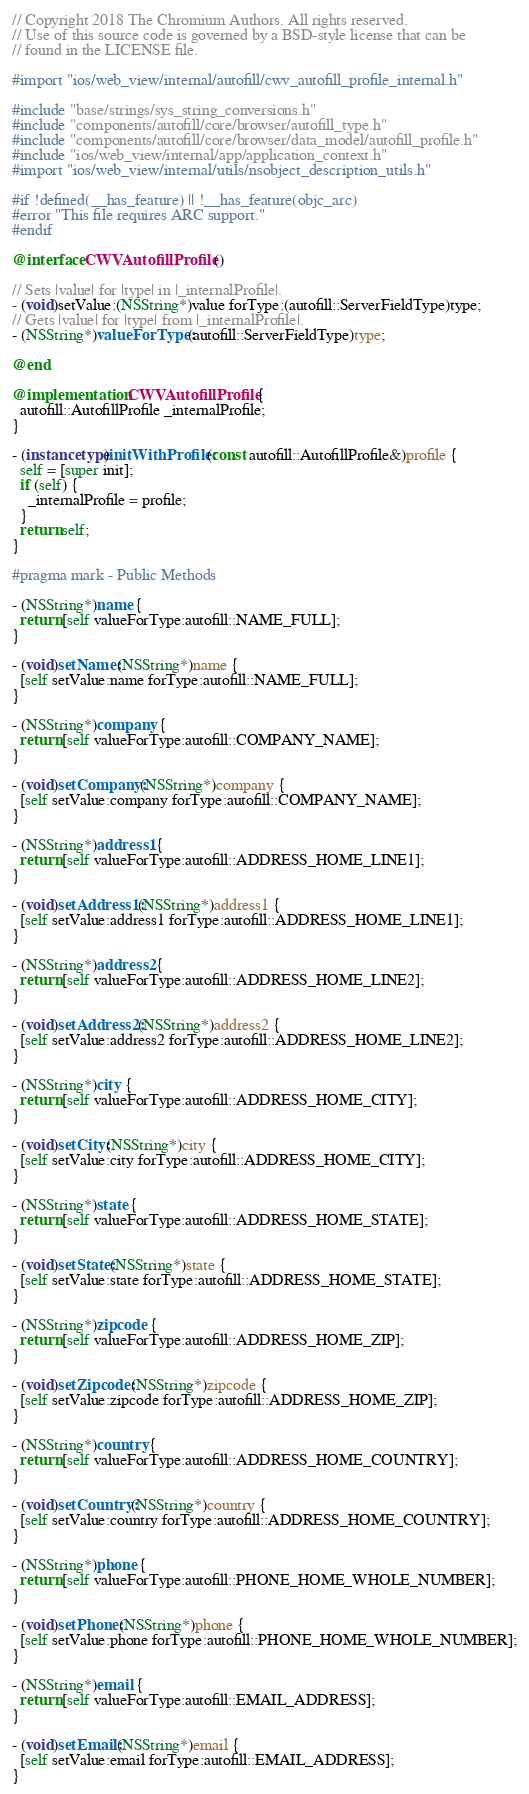<code> <loc_0><loc_0><loc_500><loc_500><_ObjectiveC_>// Copyright 2018 The Chromium Authors. All rights reserved.
// Use of this source code is governed by a BSD-style license that can be
// found in the LICENSE file.

#import "ios/web_view/internal/autofill/cwv_autofill_profile_internal.h"

#include "base/strings/sys_string_conversions.h"
#include "components/autofill/core/browser/autofill_type.h"
#include "components/autofill/core/browser/data_model/autofill_profile.h"
#include "ios/web_view/internal/app/application_context.h"
#import "ios/web_view/internal/utils/nsobject_description_utils.h"

#if !defined(__has_feature) || !__has_feature(objc_arc)
#error "This file requires ARC support."
#endif

@interface CWVAutofillProfile ()

// Sets |value| for |type| in |_internalProfile|.
- (void)setValue:(NSString*)value forType:(autofill::ServerFieldType)type;
// Gets |value| for |type| from |_internalProfile|.
- (NSString*)valueForType:(autofill::ServerFieldType)type;

@end

@implementation CWVAutofillProfile {
  autofill::AutofillProfile _internalProfile;
}

- (instancetype)initWithProfile:(const autofill::AutofillProfile&)profile {
  self = [super init];
  if (self) {
    _internalProfile = profile;
  }
  return self;
}

#pragma mark - Public Methods

- (NSString*)name {
  return [self valueForType:autofill::NAME_FULL];
}

- (void)setName:(NSString*)name {
  [self setValue:name forType:autofill::NAME_FULL];
}

- (NSString*)company {
  return [self valueForType:autofill::COMPANY_NAME];
}

- (void)setCompany:(NSString*)company {
  [self setValue:company forType:autofill::COMPANY_NAME];
}

- (NSString*)address1 {
  return [self valueForType:autofill::ADDRESS_HOME_LINE1];
}

- (void)setAddress1:(NSString*)address1 {
  [self setValue:address1 forType:autofill::ADDRESS_HOME_LINE1];
}

- (NSString*)address2 {
  return [self valueForType:autofill::ADDRESS_HOME_LINE2];
}

- (void)setAddress2:(NSString*)address2 {
  [self setValue:address2 forType:autofill::ADDRESS_HOME_LINE2];
}

- (NSString*)city {
  return [self valueForType:autofill::ADDRESS_HOME_CITY];
}

- (void)setCity:(NSString*)city {
  [self setValue:city forType:autofill::ADDRESS_HOME_CITY];
}

- (NSString*)state {
  return [self valueForType:autofill::ADDRESS_HOME_STATE];
}

- (void)setState:(NSString*)state {
  [self setValue:state forType:autofill::ADDRESS_HOME_STATE];
}

- (NSString*)zipcode {
  return [self valueForType:autofill::ADDRESS_HOME_ZIP];
}

- (void)setZipcode:(NSString*)zipcode {
  [self setValue:zipcode forType:autofill::ADDRESS_HOME_ZIP];
}

- (NSString*)country {
  return [self valueForType:autofill::ADDRESS_HOME_COUNTRY];
}

- (void)setCountry:(NSString*)country {
  [self setValue:country forType:autofill::ADDRESS_HOME_COUNTRY];
}

- (NSString*)phone {
  return [self valueForType:autofill::PHONE_HOME_WHOLE_NUMBER];
}

- (void)setPhone:(NSString*)phone {
  [self setValue:phone forType:autofill::PHONE_HOME_WHOLE_NUMBER];
}

- (NSString*)email {
  return [self valueForType:autofill::EMAIL_ADDRESS];
}

- (void)setEmail:(NSString*)email {
  [self setValue:email forType:autofill::EMAIL_ADDRESS];
}
</code> 